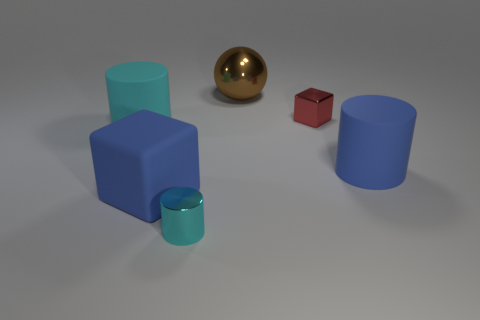There is a blue matte object that is the same shape as the small cyan object; what size is it?
Provide a succinct answer. Large. What shape is the tiny metallic thing that is behind the tiny metallic object in front of the large block?
Give a very brief answer. Cube. How many cyan objects are either rubber objects or big metallic balls?
Make the answer very short. 1. What is the color of the tiny metal block?
Provide a succinct answer. Red. Does the brown object have the same size as the red metal object?
Give a very brief answer. No. Is there anything else that is the same shape as the red metallic object?
Give a very brief answer. Yes. Are the tiny cylinder and the large blue thing that is left of the tiny block made of the same material?
Make the answer very short. No. There is a metallic thing in front of the large rubber block; does it have the same color as the tiny block?
Offer a very short reply. No. What number of big cylinders are both right of the metal block and left of the brown ball?
Provide a succinct answer. 0. What number of other things are there of the same material as the red block
Ensure brevity in your answer.  2. 